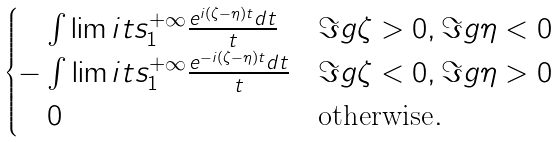Convert formula to latex. <formula><loc_0><loc_0><loc_500><loc_500>\begin{cases} \quad \int \lim i t s _ { 1 } ^ { + \infty } \frac { e ^ { i ( \zeta - \eta ) t } d t } { t } & \Im g \zeta > 0 , \Im g \eta < 0 \\ - \int \lim i t s _ { 1 } ^ { + \infty } \frac { e ^ { - i ( \zeta - \eta ) t } d t } { t } & \Im g \zeta < 0 , \Im g \eta > 0 \\ \quad 0 & \text {otherwise} . \end{cases}</formula> 